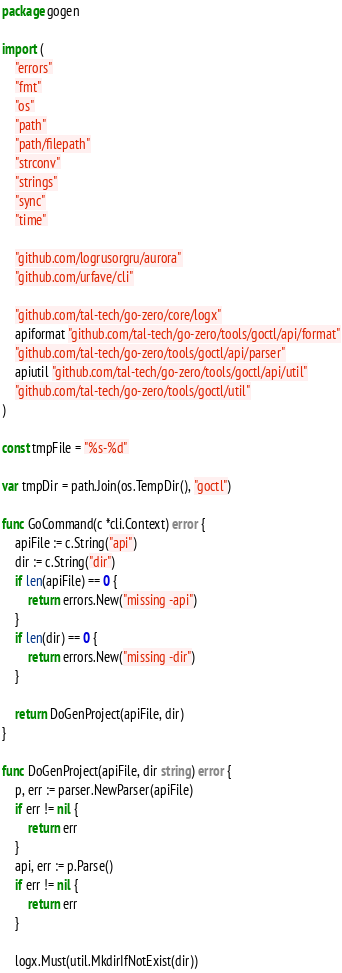<code> <loc_0><loc_0><loc_500><loc_500><_Go_>package gogen

import (
	"errors"
	"fmt"
	"os"
	"path"
	"path/filepath"
	"strconv"
	"strings"
	"sync"
	"time"

	"github.com/logrusorgru/aurora"
	"github.com/urfave/cli"

	"github.com/tal-tech/go-zero/core/logx"
	apiformat "github.com/tal-tech/go-zero/tools/goctl/api/format"
	"github.com/tal-tech/go-zero/tools/goctl/api/parser"
	apiutil "github.com/tal-tech/go-zero/tools/goctl/api/util"
	"github.com/tal-tech/go-zero/tools/goctl/util"
)

const tmpFile = "%s-%d"

var tmpDir = path.Join(os.TempDir(), "goctl")

func GoCommand(c *cli.Context) error {
	apiFile := c.String("api")
	dir := c.String("dir")
	if len(apiFile) == 0 {
		return errors.New("missing -api")
	}
	if len(dir) == 0 {
		return errors.New("missing -dir")
	}

	return DoGenProject(apiFile, dir)
}

func DoGenProject(apiFile, dir string) error {
	p, err := parser.NewParser(apiFile)
	if err != nil {
		return err
	}
	api, err := p.Parse()
	if err != nil {
		return err
	}

	logx.Must(util.MkdirIfNotExist(dir))</code> 